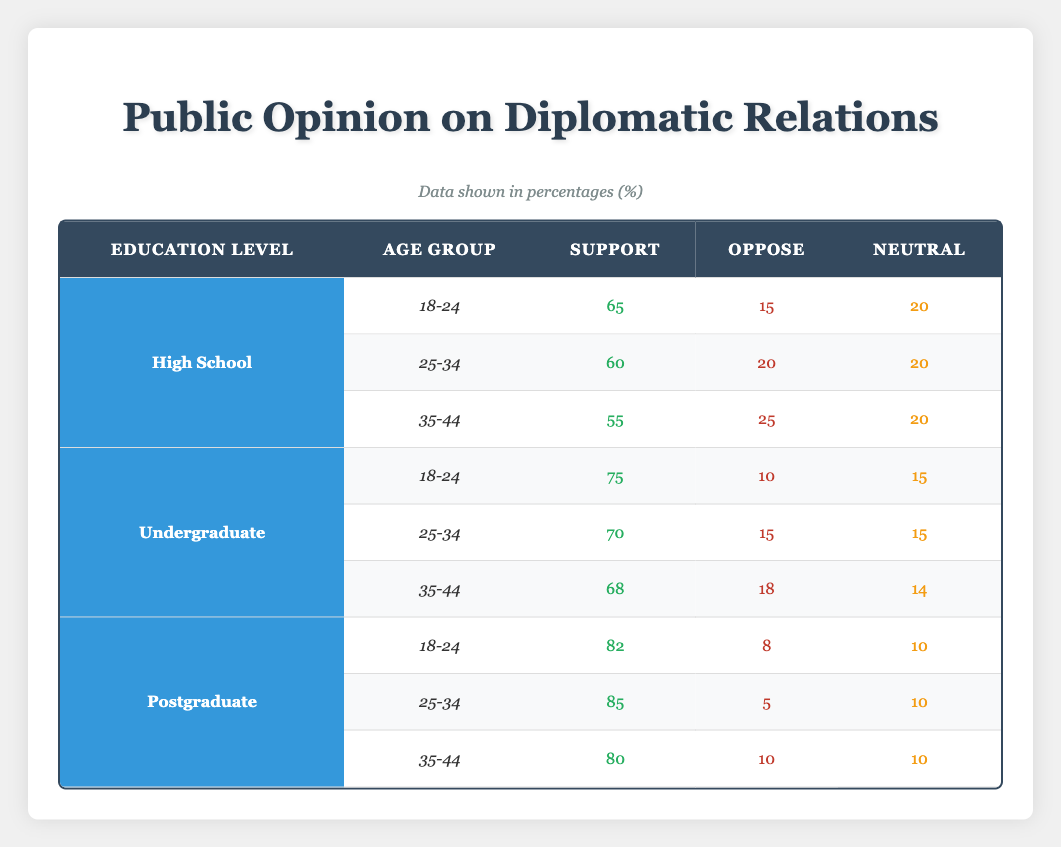What percentage of individuals aged 18-24 with a postgraduate education support diplomatic relations? According to the data, individuals in the 18-24 age group with postgraduate education show a support percentage of 82.
Answer: 82 What is the percentage of individuals aged 35-44 with a high school education who oppose diplomatic relations? The table shows that among individuals aged 35-44 with a high school education, 25% oppose diplomatic relations.
Answer: 25 Which age group shows the highest support for diplomatic relations among undergraduate-educated individuals? For undergraduate individuals, the age group 18-24 shows the highest support at 75%. This is more compared to the 25-34 and 35-44 age groups, which have 70% and 68% support respectively.
Answer: 18-24 Is it true that more postgraduate graduates oppose diplomatic relations than those with a high school education in the 25-34 age group? In the 25-34 age group, postgraduate graduates oppose diplomatic relations at 5%, while high school graduates oppose at 20%. Thus, it is false that more postgraduate graduates oppose relations compared to high school graduates.
Answer: No What is the average support for diplomatic relations across all age groups for individuals with a high school education? The support percentages for high school education in the 18-24, 25-34, and 35-44 age groups are 65, 60, and 55 respectively. Adding these gives 180, and dividing by 3 yields an average support of 60%.
Answer: 60 